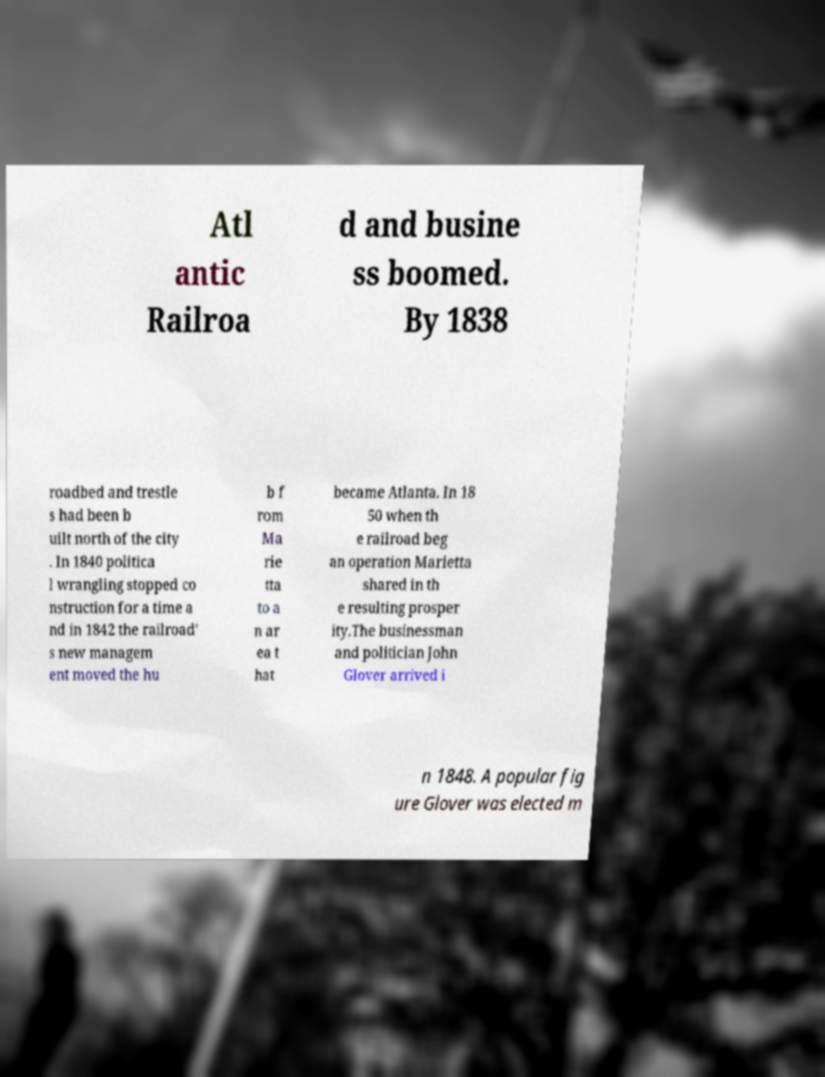Could you extract and type out the text from this image? Atl antic Railroa d and busine ss boomed. By 1838 roadbed and trestle s had been b uilt north of the city . In 1840 politica l wrangling stopped co nstruction for a time a nd in 1842 the railroad' s new managem ent moved the hu b f rom Ma rie tta to a n ar ea t hat became Atlanta. In 18 50 when th e railroad beg an operation Marietta shared in th e resulting prosper ity.The businessman and politician John Glover arrived i n 1848. A popular fig ure Glover was elected m 